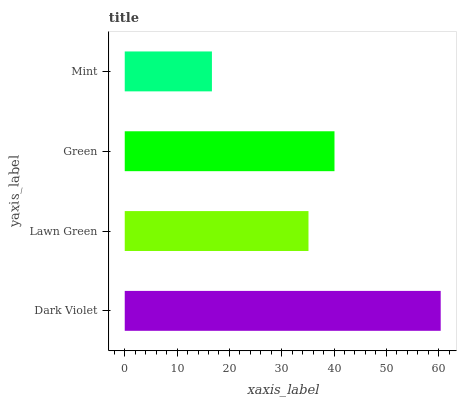Is Mint the minimum?
Answer yes or no. Yes. Is Dark Violet the maximum?
Answer yes or no. Yes. Is Lawn Green the minimum?
Answer yes or no. No. Is Lawn Green the maximum?
Answer yes or no. No. Is Dark Violet greater than Lawn Green?
Answer yes or no. Yes. Is Lawn Green less than Dark Violet?
Answer yes or no. Yes. Is Lawn Green greater than Dark Violet?
Answer yes or no. No. Is Dark Violet less than Lawn Green?
Answer yes or no. No. Is Green the high median?
Answer yes or no. Yes. Is Lawn Green the low median?
Answer yes or no. Yes. Is Dark Violet the high median?
Answer yes or no. No. Is Green the low median?
Answer yes or no. No. 